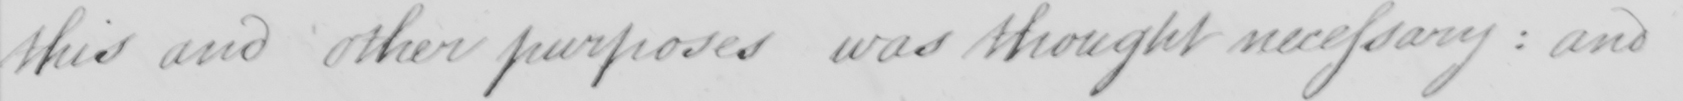Can you read and transcribe this handwriting? this and other purposes was thought necessary: and 